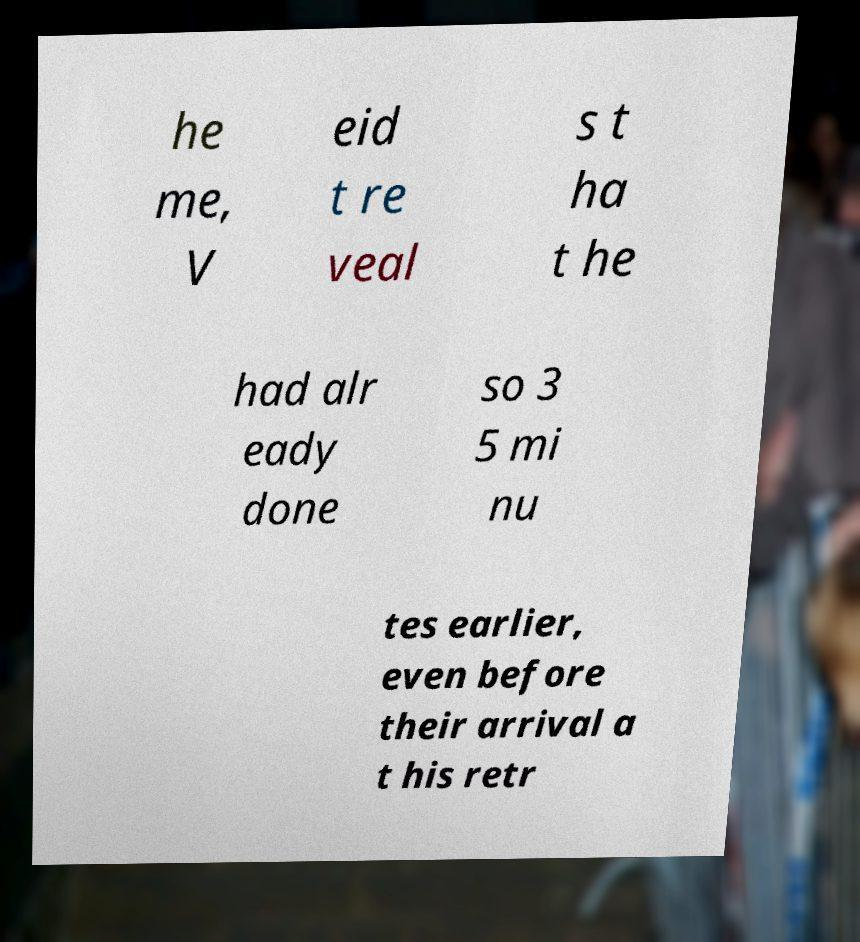Could you assist in decoding the text presented in this image and type it out clearly? he me, V eid t re veal s t ha t he had alr eady done so 3 5 mi nu tes earlier, even before their arrival a t his retr 